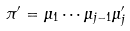Convert formula to latex. <formula><loc_0><loc_0><loc_500><loc_500>\pi ^ { \prime } = \mu _ { 1 } \cdots \mu _ { j - 1 } \mu ^ { \prime } _ { j }</formula> 